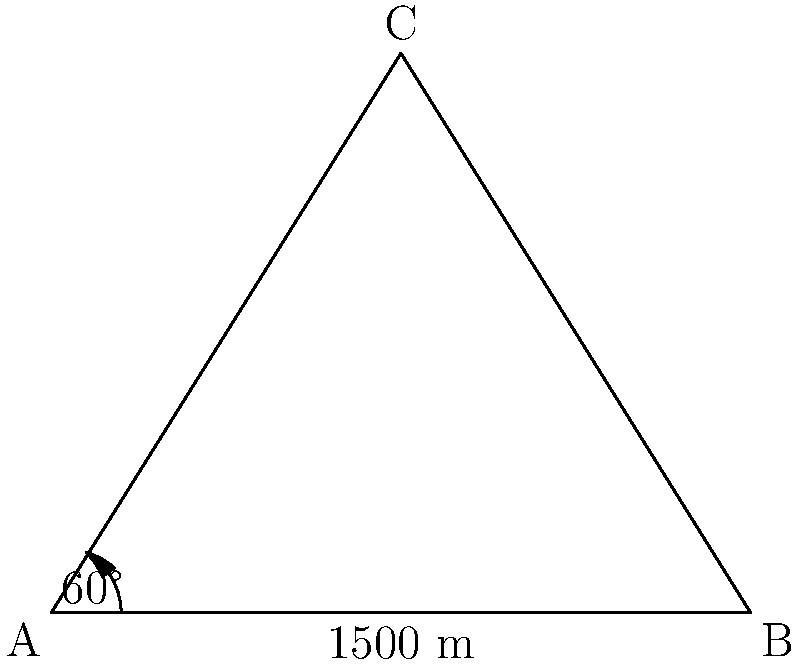As a venture capitalist interested in Swiss startups, you're evaluating a new drone technology for mountain surveying. To test its accuracy, you decide to measure the height of a famous Swiss mountain peak. From a vantage point A, you observe the peak C at an angle of elevation of 60°. You then move 1500 meters along flat ground to point B, directly towards the base of the peak. What is the height of the mountain peak in meters? Let's approach this step-by-step:

1) We can use the tangent ratio in the right-angled triangle formed by the observer's position, the base of the mountain, and its peak.

2) In the triangle ABC:
   - AB is the known distance of 1500 m
   - Angle CAB is 60°
   - We need to find the height BC

3) We can use the tangent of 60°:

   $\tan 60° = \frac{BC}{AB/2}$

4) We know that $\tan 60° = \sqrt{3}$, so:

   $\sqrt{3} = \frac{BC}{750}$

5) Solving for BC:

   $BC = 750\sqrt{3}$

6) Calculate the value:

   $BC = 750 * 1.732050808 \approx 1299.04$ m

Therefore, the height of the mountain peak is approximately 1299.04 meters.
Answer: 1299.04 m 